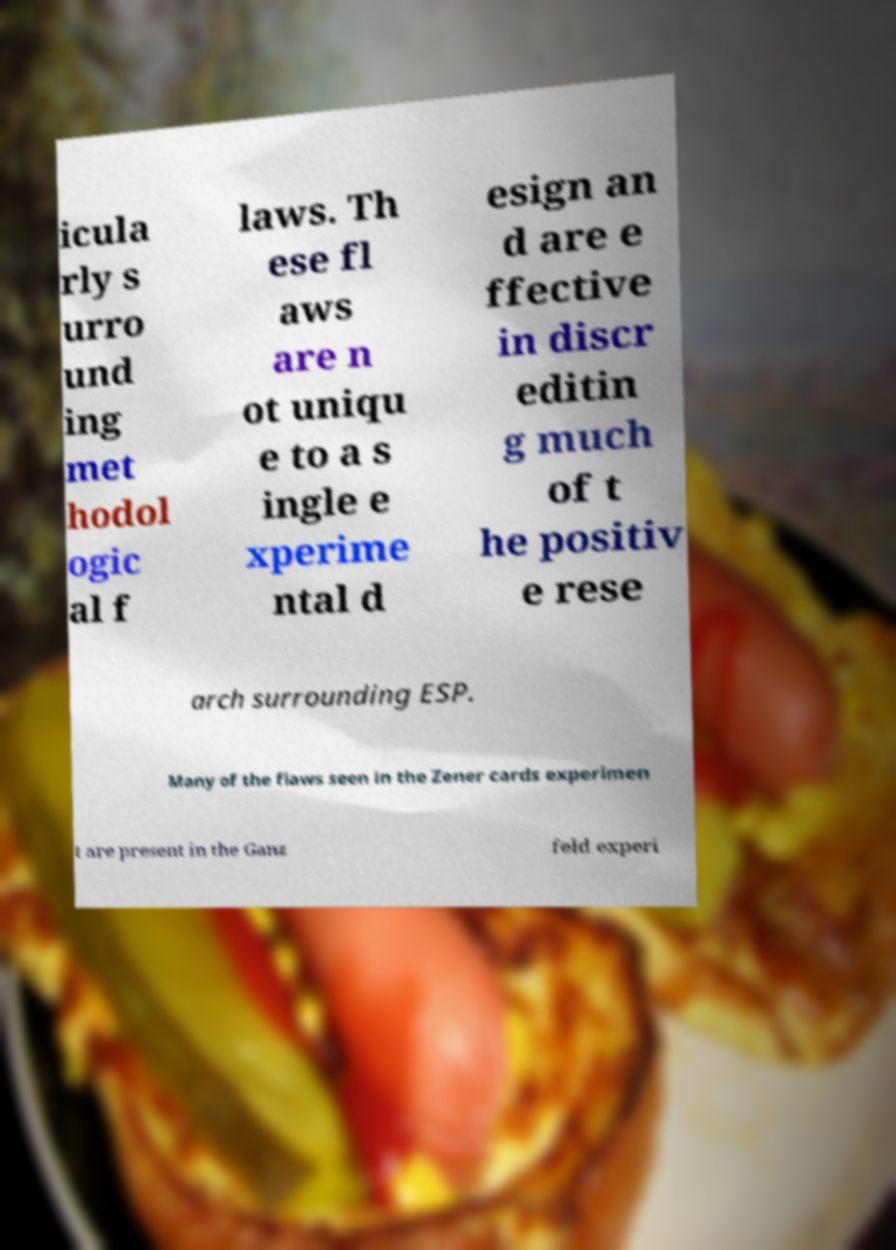Can you read and provide the text displayed in the image?This photo seems to have some interesting text. Can you extract and type it out for me? icula rly s urro und ing met hodol ogic al f laws. Th ese fl aws are n ot uniqu e to a s ingle e xperime ntal d esign an d are e ffective in discr editin g much of t he positiv e rese arch surrounding ESP. Many of the flaws seen in the Zener cards experimen t are present in the Ganz feld experi 